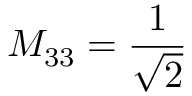Convert formula to latex. <formula><loc_0><loc_0><loc_500><loc_500>M _ { 3 3 } = \frac { 1 } { \sqrt { 2 } }</formula> 